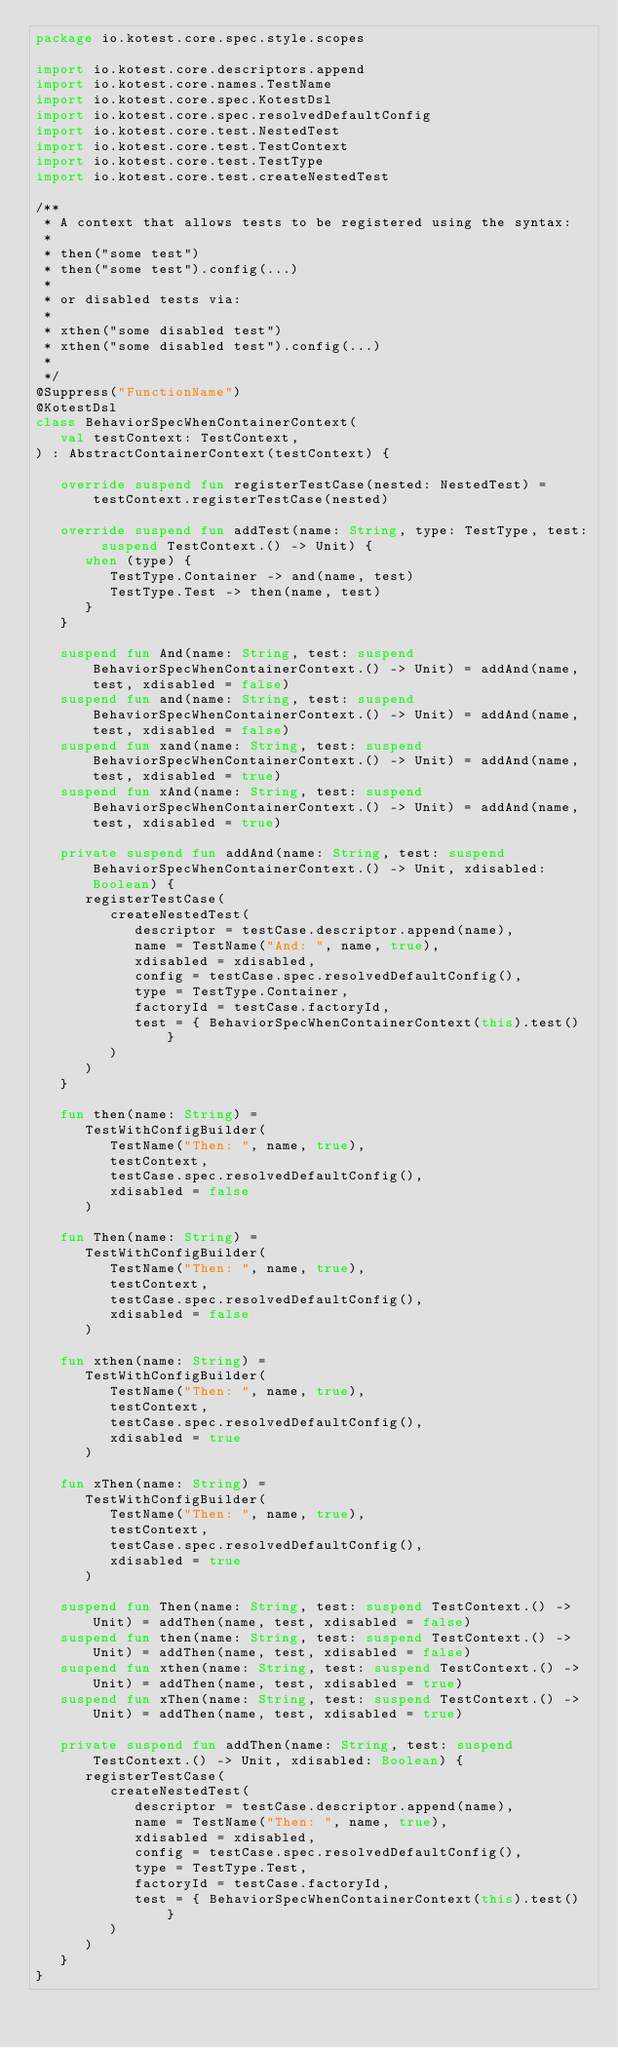<code> <loc_0><loc_0><loc_500><loc_500><_Kotlin_>package io.kotest.core.spec.style.scopes

import io.kotest.core.descriptors.append
import io.kotest.core.names.TestName
import io.kotest.core.spec.KotestDsl
import io.kotest.core.spec.resolvedDefaultConfig
import io.kotest.core.test.NestedTest
import io.kotest.core.test.TestContext
import io.kotest.core.test.TestType
import io.kotest.core.test.createNestedTest

/**
 * A context that allows tests to be registered using the syntax:
 *
 * then("some test")
 * then("some test").config(...)
 *
 * or disabled tests via:
 *
 * xthen("some disabled test")
 * xthen("some disabled test").config(...)
 *
 */
@Suppress("FunctionName")
@KotestDsl
class BehaviorSpecWhenContainerContext(
   val testContext: TestContext,
) : AbstractContainerContext(testContext) {

   override suspend fun registerTestCase(nested: NestedTest) = testContext.registerTestCase(nested)

   override suspend fun addTest(name: String, type: TestType, test: suspend TestContext.() -> Unit) {
      when (type) {
         TestType.Container -> and(name, test)
         TestType.Test -> then(name, test)
      }
   }

   suspend fun And(name: String, test: suspend BehaviorSpecWhenContainerContext.() -> Unit) = addAnd(name, test, xdisabled = false)
   suspend fun and(name: String, test: suspend BehaviorSpecWhenContainerContext.() -> Unit) = addAnd(name, test, xdisabled = false)
   suspend fun xand(name: String, test: suspend BehaviorSpecWhenContainerContext.() -> Unit) = addAnd(name, test, xdisabled = true)
   suspend fun xAnd(name: String, test: suspend BehaviorSpecWhenContainerContext.() -> Unit) = addAnd(name, test, xdisabled = true)

   private suspend fun addAnd(name: String, test: suspend BehaviorSpecWhenContainerContext.() -> Unit, xdisabled: Boolean) {
      registerTestCase(
         createNestedTest(
            descriptor = testCase.descriptor.append(name),
            name = TestName("And: ", name, true),
            xdisabled = xdisabled,
            config = testCase.spec.resolvedDefaultConfig(),
            type = TestType.Container,
            factoryId = testCase.factoryId,
            test = { BehaviorSpecWhenContainerContext(this).test() }
         )
      )
   }

   fun then(name: String) =
      TestWithConfigBuilder(
         TestName("Then: ", name, true),
         testContext,
         testCase.spec.resolvedDefaultConfig(),
         xdisabled = false
      )

   fun Then(name: String) =
      TestWithConfigBuilder(
         TestName("Then: ", name, true),
         testContext,
         testCase.spec.resolvedDefaultConfig(),
         xdisabled = false
      )

   fun xthen(name: String) =
      TestWithConfigBuilder(
         TestName("Then: ", name, true),
         testContext,
         testCase.spec.resolvedDefaultConfig(),
         xdisabled = true
      )

   fun xThen(name: String) =
      TestWithConfigBuilder(
         TestName("Then: ", name, true),
         testContext,
         testCase.spec.resolvedDefaultConfig(),
         xdisabled = true
      )

   suspend fun Then(name: String, test: suspend TestContext.() -> Unit) = addThen(name, test, xdisabled = false)
   suspend fun then(name: String, test: suspend TestContext.() -> Unit) = addThen(name, test, xdisabled = false)
   suspend fun xthen(name: String, test: suspend TestContext.() -> Unit) = addThen(name, test, xdisabled = true)
   suspend fun xThen(name: String, test: suspend TestContext.() -> Unit) = addThen(name, test, xdisabled = true)

   private suspend fun addThen(name: String, test: suspend TestContext.() -> Unit, xdisabled: Boolean) {
      registerTestCase(
         createNestedTest(
            descriptor = testCase.descriptor.append(name),
            name = TestName("Then: ", name, true),
            xdisabled = xdisabled,
            config = testCase.spec.resolvedDefaultConfig(),
            type = TestType.Test,
            factoryId = testCase.factoryId,
            test = { BehaviorSpecWhenContainerContext(this).test() }
         )
      )
   }
}
</code> 